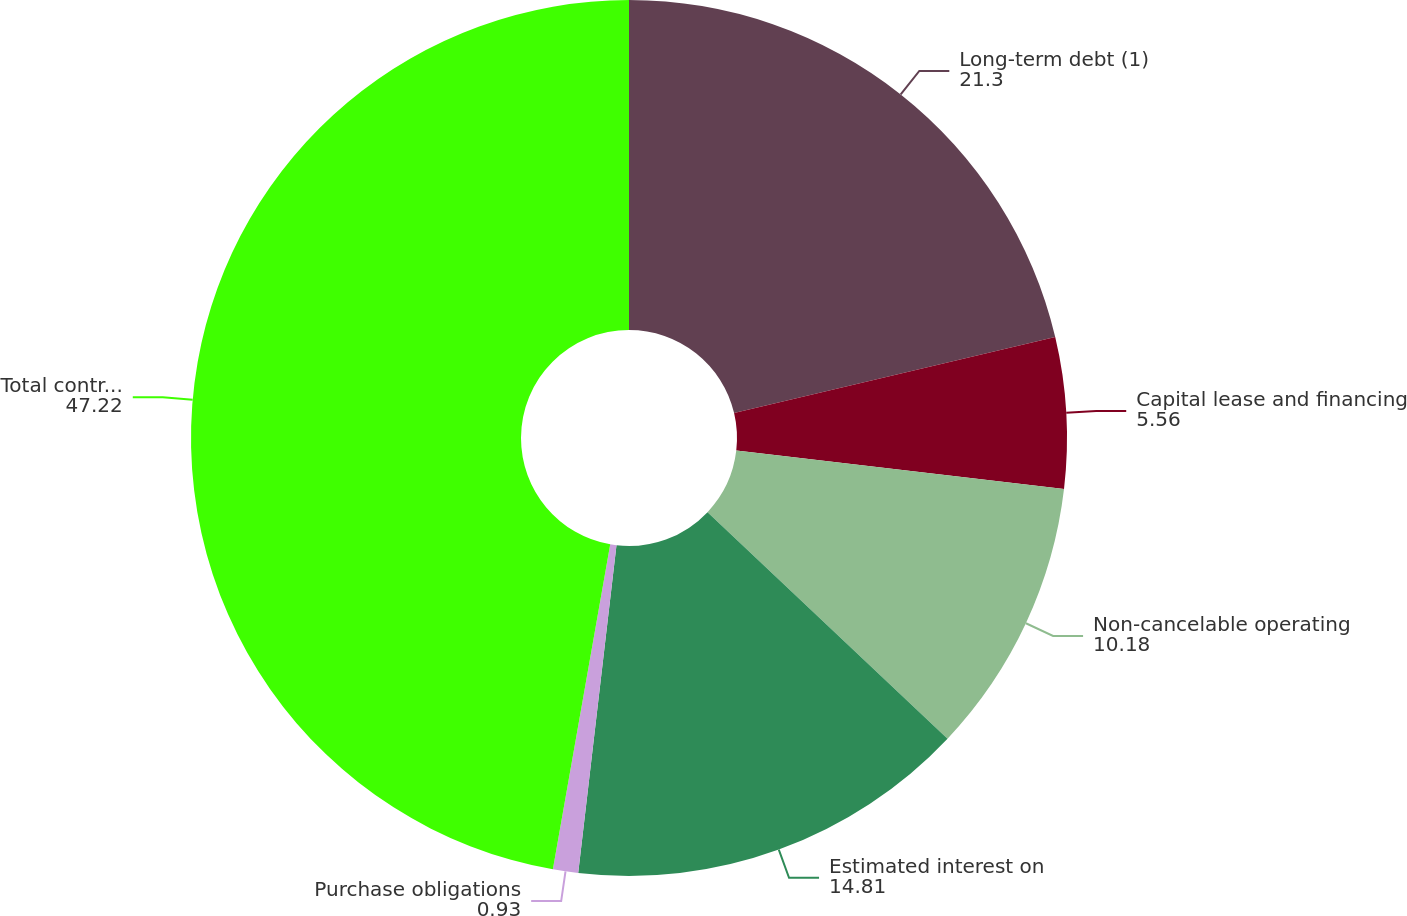Convert chart. <chart><loc_0><loc_0><loc_500><loc_500><pie_chart><fcel>Long-term debt (1)<fcel>Capital lease and financing<fcel>Non-cancelable operating<fcel>Estimated interest on<fcel>Purchase obligations<fcel>Total contractual obligations<nl><fcel>21.3%<fcel>5.56%<fcel>10.18%<fcel>14.81%<fcel>0.93%<fcel>47.22%<nl></chart> 